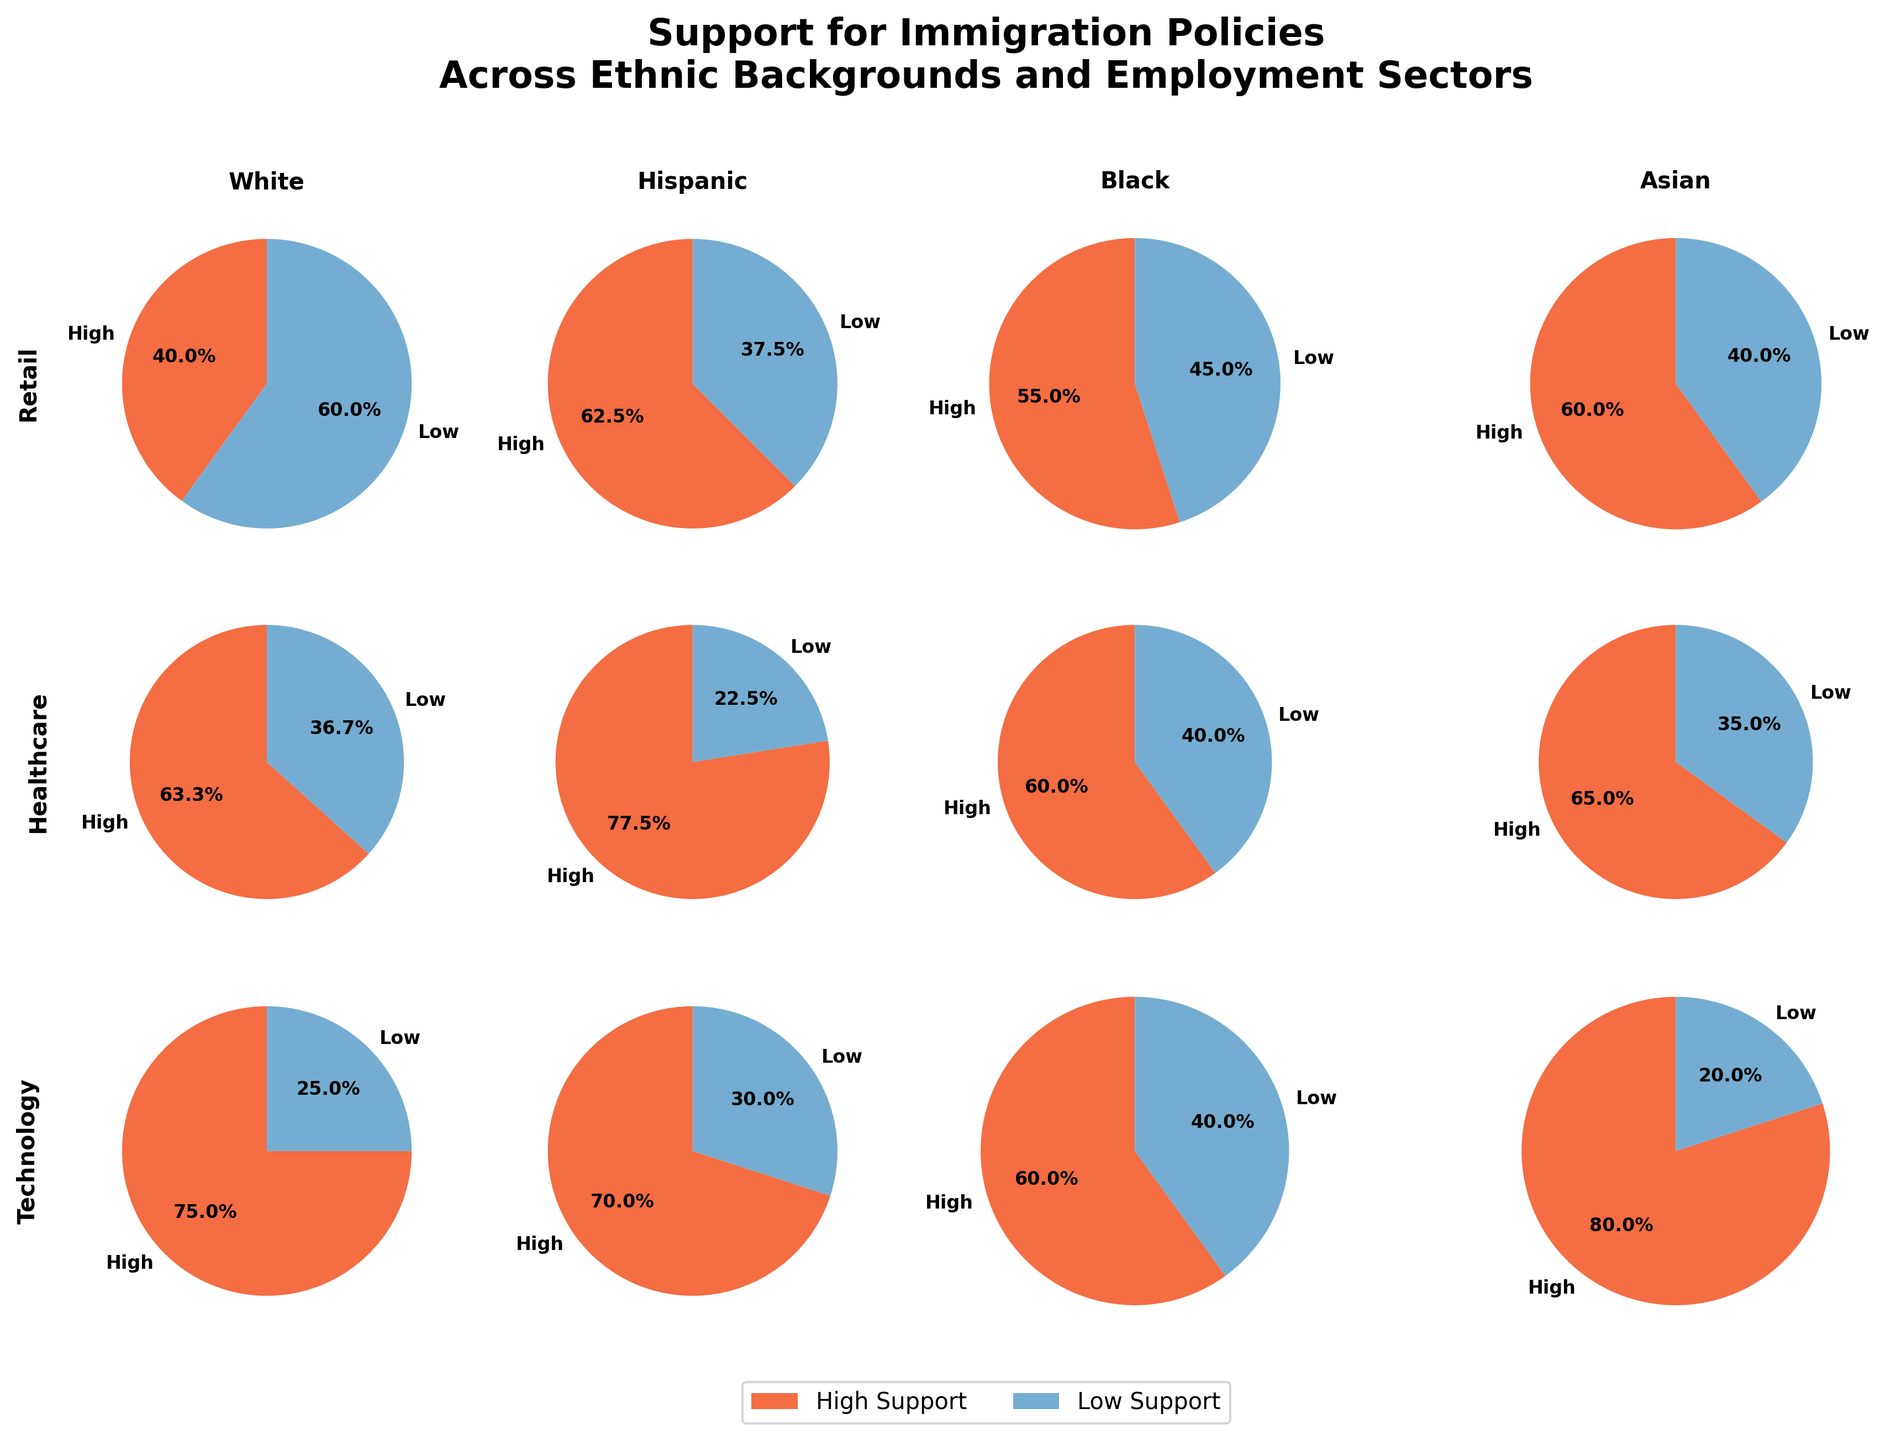What is the title of the plot? Look at the top of the plot where the title is generally located. The title helps to quickly understand the context of the data presented.
Answer: Support for Immigration Policies Across Ethnic Backgrounds and Employment Sectors Which employment sector shows the highest support for immigration policies among Hispanic individuals? Identify the Hispanic segment and compare the support levels across different employment sectors. High support levels are typically indicated by larger pie slices for 'High' support.
Answer: Healthcare Among Asian individuals, which sector has the lowest level of support for immigration policies? Look at the Asian segment and compare the support levels across different employment sectors. The sector with a larger slice for 'Low' support indicates a lower level of support.
Answer: Technology How does the support for immigration policies in the Retail sector compare across different ethnicities? Compare the size of the 'High' and 'Low' support slices in the Retail sector for each ethnicity. The trends should reveal which ethnic groups show more or less support within this sector.
Answer: Varies, with White showing more 'Low' support and others showing more evenly divided support Which ethnic group exhibits the greatest overall support for immigration policies across all employment sectors? Assess the pie slices labeled 'High' across all employment sectors for each ethnic group. The group with the most 'High' support slices or largest aggregate 'High' slices indicates higher overall support.
Answer: Hispanic What proportion of White individuals in the Technology sector support high levels of immigration policies? Find the Technology sector for White individuals and look at the pie slices; calculate the percentage represented by the 'High' support slice. The plot typically shows this percentage directly.
Answer: 75% In the Healthcare sector, which ethnic group shows the most balanced support levels for immigration policies? Review the Healthcare sector’s pie charts across different ethnic groups. Identify the group with nearly equal-sized slices for 'High' and 'Low' support.
Answer: Asian Compare the support levels between Black and Hispanic individuals in the Retail sector. Look at the Retail sector pie charts for both Black and Hispanic individuals, comparing the size of 'High' and 'Low' support slices to determine which has higher or lower support levels.
Answer: Black has higher 'High' support than Hispanic What is the relative support for immigration policies among Asian and Black individuals in the Technology sector? Evaluate the Technology sector's pie charts for both Asian and Black groups, comparing the size of 'High' and 'Low' support slices to determine relative support levels.
Answer: Asian shows higher 'High' support than Black 